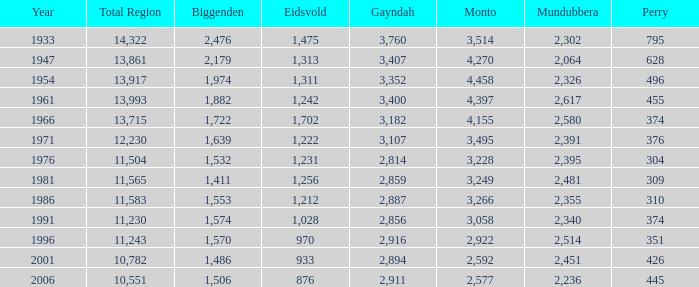In what year are mundubbera's and biggenden's sizes below 2,395 and 1,506 respectively? None. 